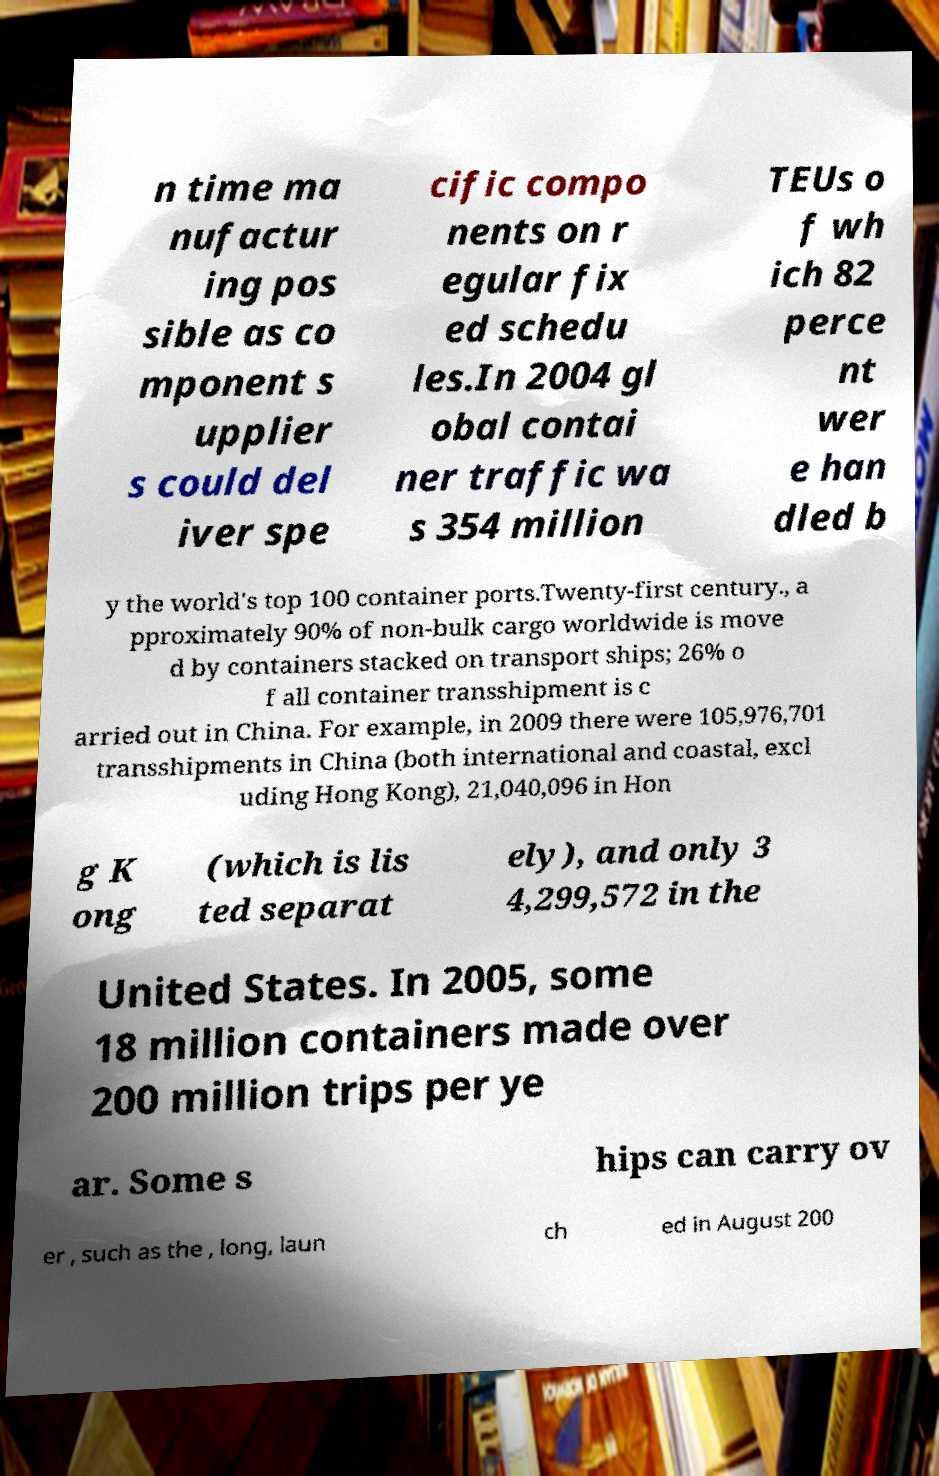Can you read and provide the text displayed in the image?This photo seems to have some interesting text. Can you extract and type it out for me? n time ma nufactur ing pos sible as co mponent s upplier s could del iver spe cific compo nents on r egular fix ed schedu les.In 2004 gl obal contai ner traffic wa s 354 million TEUs o f wh ich 82 perce nt wer e han dled b y the world's top 100 container ports.Twenty-first century., a pproximately 90% of non-bulk cargo worldwide is move d by containers stacked on transport ships; 26% o f all container transshipment is c arried out in China. For example, in 2009 there were 105,976,701 transshipments in China (both international and coastal, excl uding Hong Kong), 21,040,096 in Hon g K ong (which is lis ted separat ely), and only 3 4,299,572 in the United States. In 2005, some 18 million containers made over 200 million trips per ye ar. Some s hips can carry ov er , such as the , long, laun ch ed in August 200 